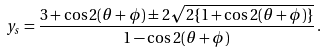<formula> <loc_0><loc_0><loc_500><loc_500>y _ { s } = \frac { 3 + \cos 2 ( \theta + \phi ) \pm 2 \sqrt { 2 \{ 1 + \cos 2 ( \theta + \phi ) \} } } { 1 - \cos 2 ( \theta + \phi ) } \, .</formula> 